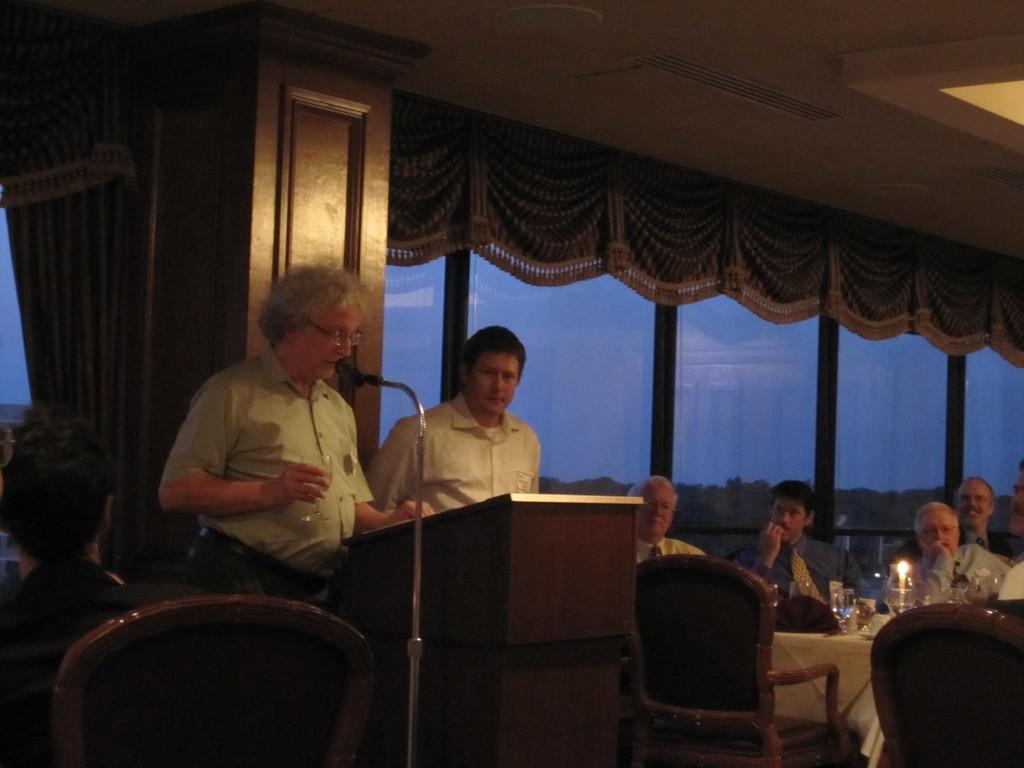How would you summarize this image in a sentence or two? In this image I can see 2 people standing, there is a microphone and a speech desk in the center. There are tables and chairs. People are seated on the chairs and there are glasses, candle and other objects on the table. There are glass windows and curtains at the back. 